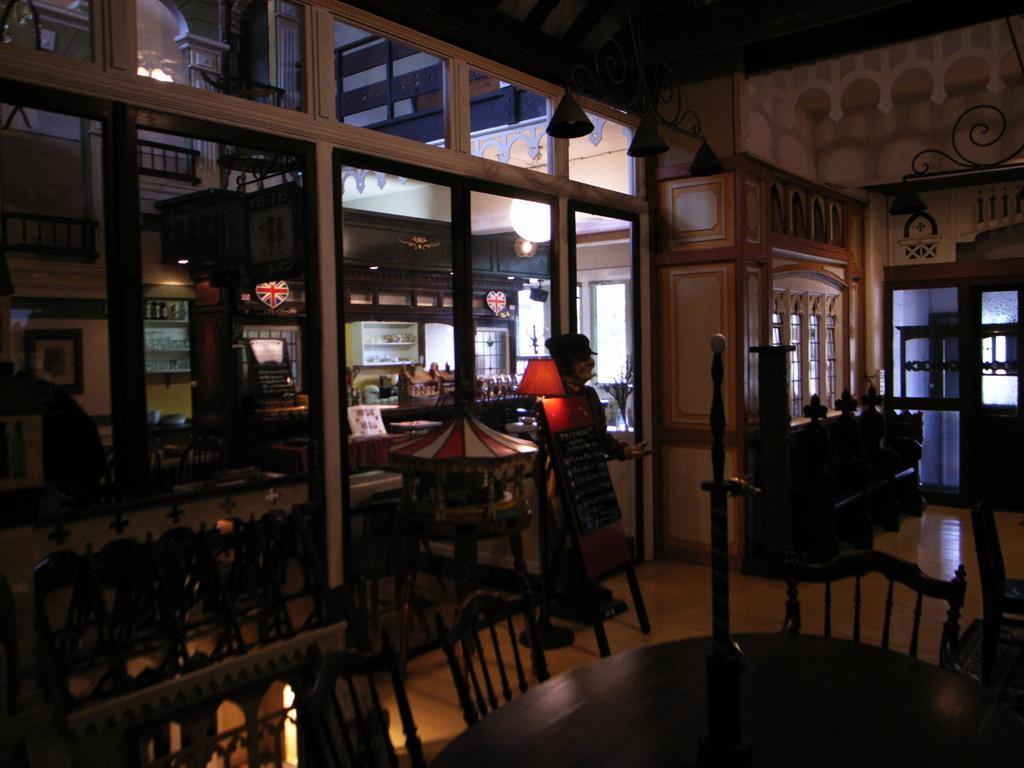Can you describe this image briefly? In this picture we can see many tables, chairs, cupboards with drawers, light lamps etc., on the wooden floor. We have many windows and doors with glass panes. 